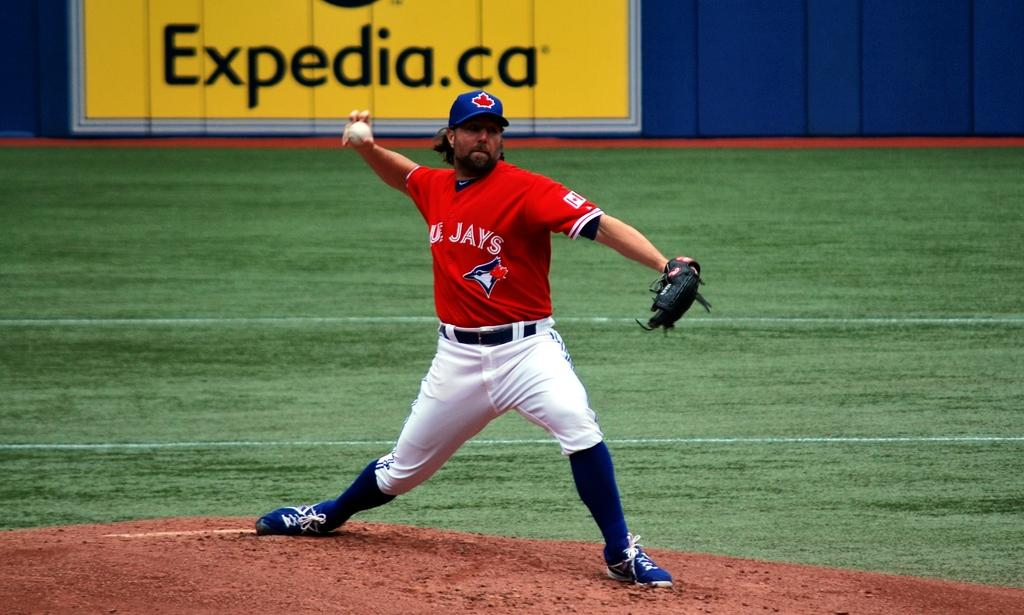<image>
Provide a brief description of the given image. A baseball player in a red and white uniform for the Blue Jays delivers a pitch. 